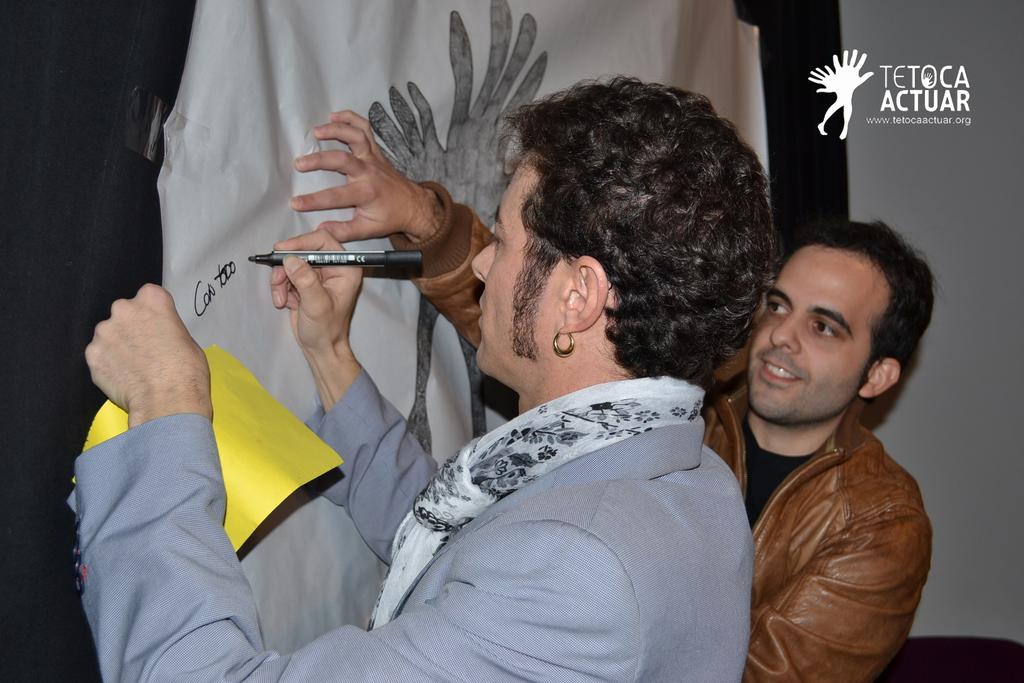How many people are present in the image? There are two men standing in the image. What is one of the men doing in the image? One man is writing on the curtain with a marker. What is the man holding while writing on the curtain? The man is holding a cloth. What type of summer clothing is the man wearing in the image? The provided facts do not mention any clothing or the season, so we cannot determine the type of summer clothing the man is wearing. 